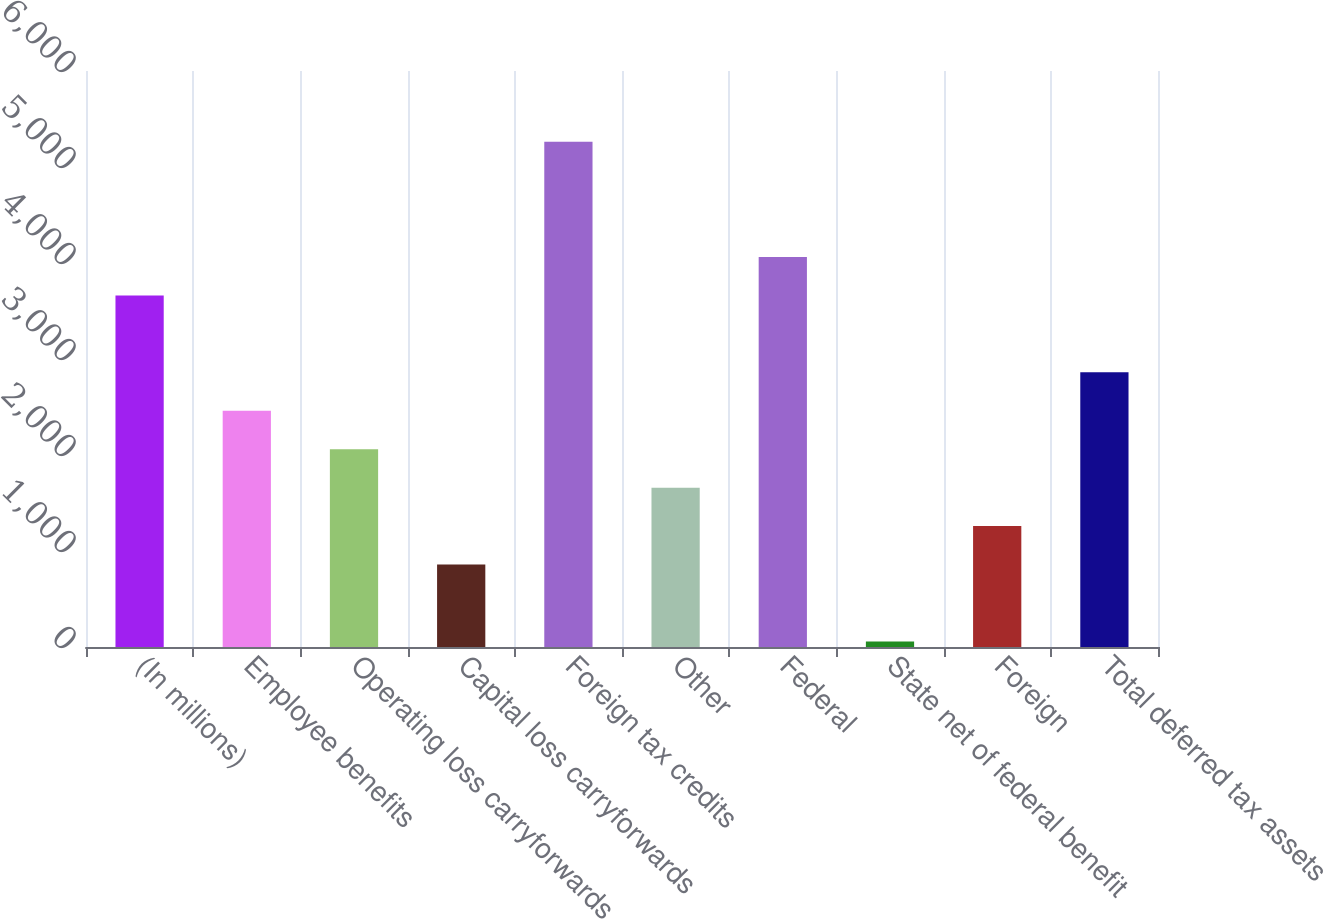Convert chart. <chart><loc_0><loc_0><loc_500><loc_500><bar_chart><fcel>(In millions)<fcel>Employee benefits<fcel>Operating loss carryforwards<fcel>Capital loss carryforwards<fcel>Foreign tax credits<fcel>Other<fcel>Federal<fcel>State net of federal benefit<fcel>Foreign<fcel>Total deferred tax assets<nl><fcel>3661.6<fcel>2460.4<fcel>2060<fcel>858.8<fcel>5263.2<fcel>1659.6<fcel>4062<fcel>58<fcel>1259.2<fcel>2860.8<nl></chart> 